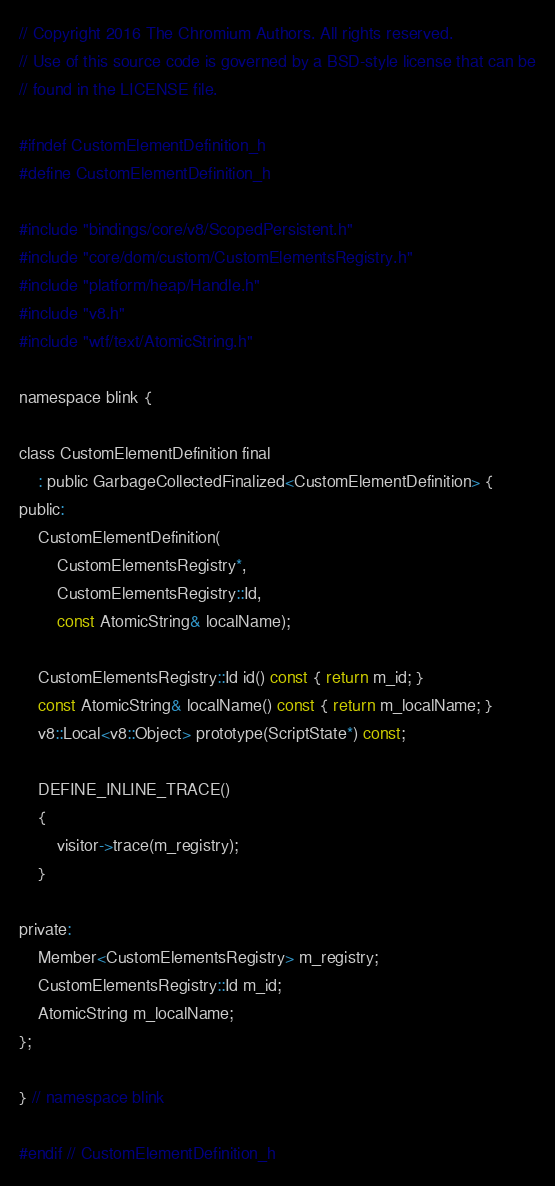Convert code to text. <code><loc_0><loc_0><loc_500><loc_500><_C_>// Copyright 2016 The Chromium Authors. All rights reserved.
// Use of this source code is governed by a BSD-style license that can be
// found in the LICENSE file.

#ifndef CustomElementDefinition_h
#define CustomElementDefinition_h

#include "bindings/core/v8/ScopedPersistent.h"
#include "core/dom/custom/CustomElementsRegistry.h"
#include "platform/heap/Handle.h"
#include "v8.h"
#include "wtf/text/AtomicString.h"

namespace blink {

class CustomElementDefinition final
    : public GarbageCollectedFinalized<CustomElementDefinition> {
public:
    CustomElementDefinition(
        CustomElementsRegistry*,
        CustomElementsRegistry::Id,
        const AtomicString& localName);

    CustomElementsRegistry::Id id() const { return m_id; }
    const AtomicString& localName() const { return m_localName; }
    v8::Local<v8::Object> prototype(ScriptState*) const;

    DEFINE_INLINE_TRACE()
    {
        visitor->trace(m_registry);
    }

private:
    Member<CustomElementsRegistry> m_registry;
    CustomElementsRegistry::Id m_id;
    AtomicString m_localName;
};

} // namespace blink

#endif // CustomElementDefinition_h
</code> 